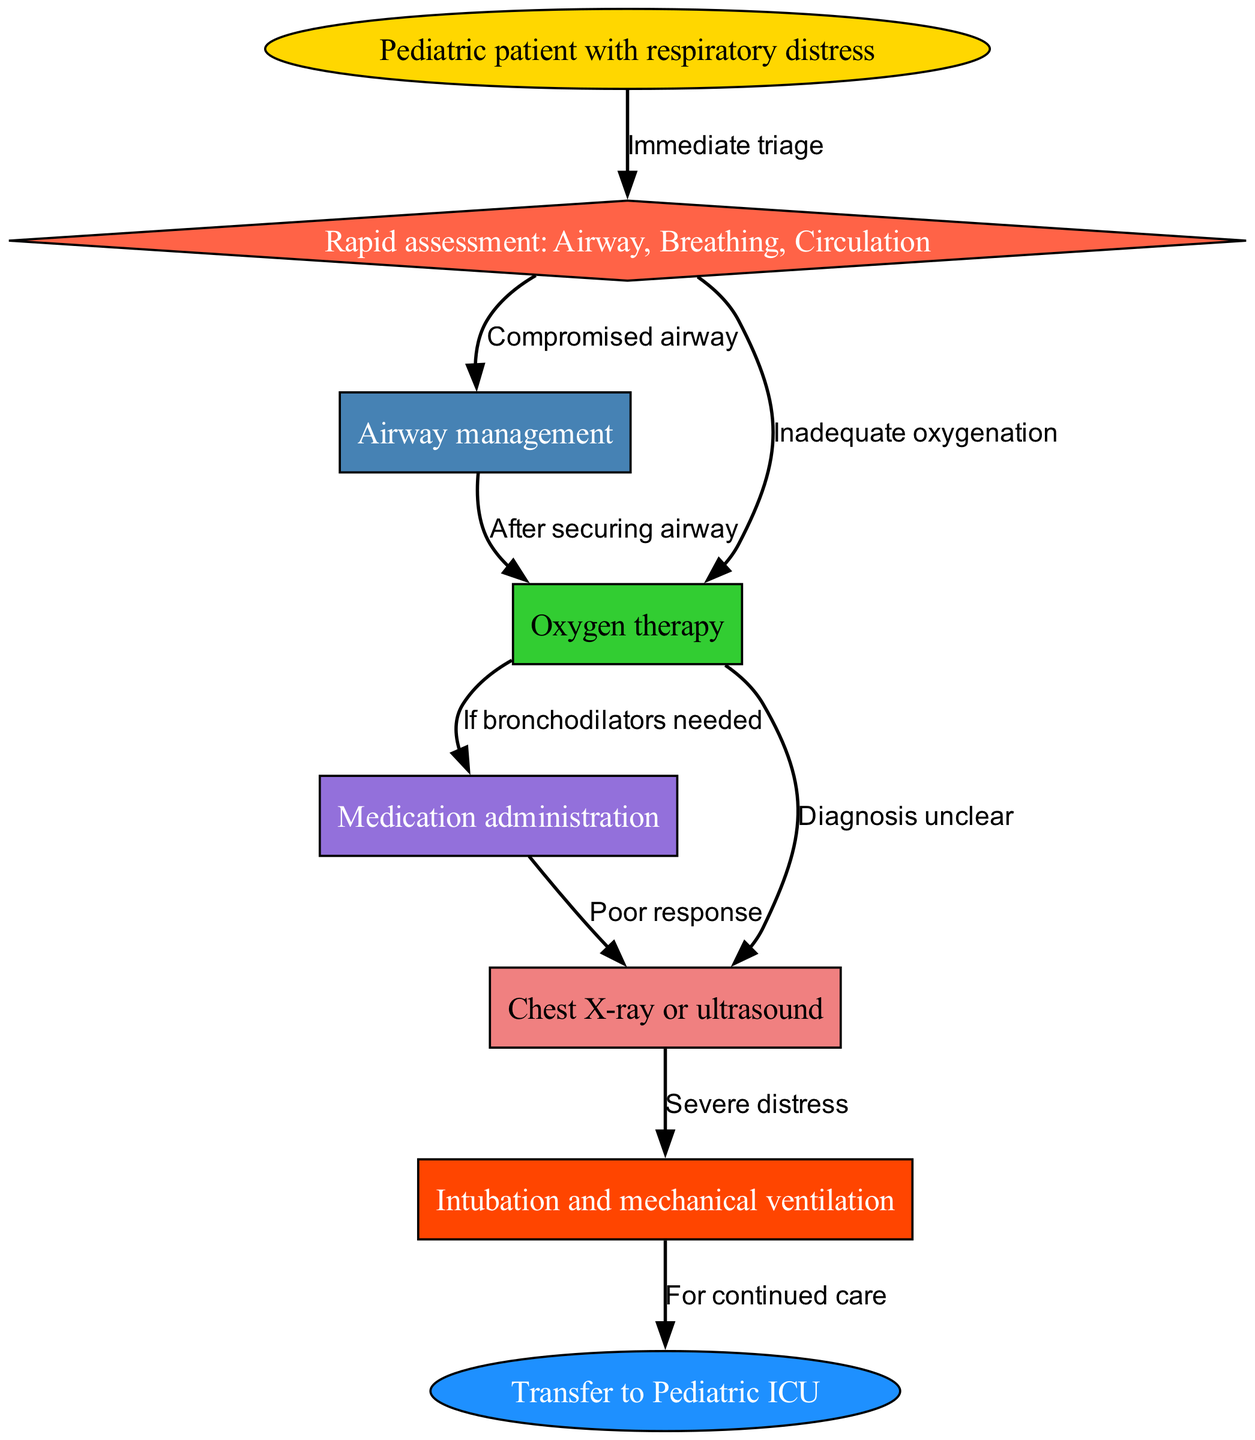What is the first step in managing respiratory distress in pediatric patients? The diagram indicates that the first step is "Rapid assessment: Airway, Breathing, Circulation," which comes immediately after the initial identification of the patient with respiratory distress.
Answer: Rapid assessment: Airway, Breathing, Circulation How many edges are there in the diagram? By counting the connections between nodes (edges), we find a total of 9 edges representing the various decision paths in managing respiratory distress.
Answer: 9 What action is taken if there is a compromised airway? According to the diagram, if there is a compromised airway identified during the assessment, it leads directly to "Airway management."
Answer: Airway management What is the outcome of severe distress according to the imaging step? The diagram shows that if imaging reveals "Severe distress," the next action taken is "Intubation and mechanical ventilation."
Answer: Intubation and mechanical ventilation Which node represents the transfer for continued care? The final step illustrated in the diagram is "Transfer to Pediatric ICU," which indicates where the patient goes after intubation.
Answer: Transfer to Pediatric ICU If bronchodilators are needed, what is the next step? The diagram specifies that if bronchodilators are needed after oxygenation, the path leads to "Medication administration."
Answer: Medication administration What does the node labeled "Oxygen therapy" connect to if the diagnosis is unclear? If the diagnosis is unclear after evaluating oxygenation, the diagram illustrates that it leads to "Chest X-ray or ultrasound."
Answer: Chest X-ray or ultrasound How does the path flow from "Intubation and mechanical ventilation"? According to the flow in the diagram, after "Intubation and mechanical ventilation," the patient will then be transferred to the "Pediatric ICU" for continued care.
Answer: Transfer to Pediatric ICU 